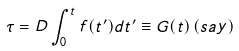<formula> <loc_0><loc_0><loc_500><loc_500>\tau = D \int _ { 0 } ^ { t } f ( t ^ { \prime } ) d t ^ { \prime } \equiv G ( t ) \, ( s a y )</formula> 